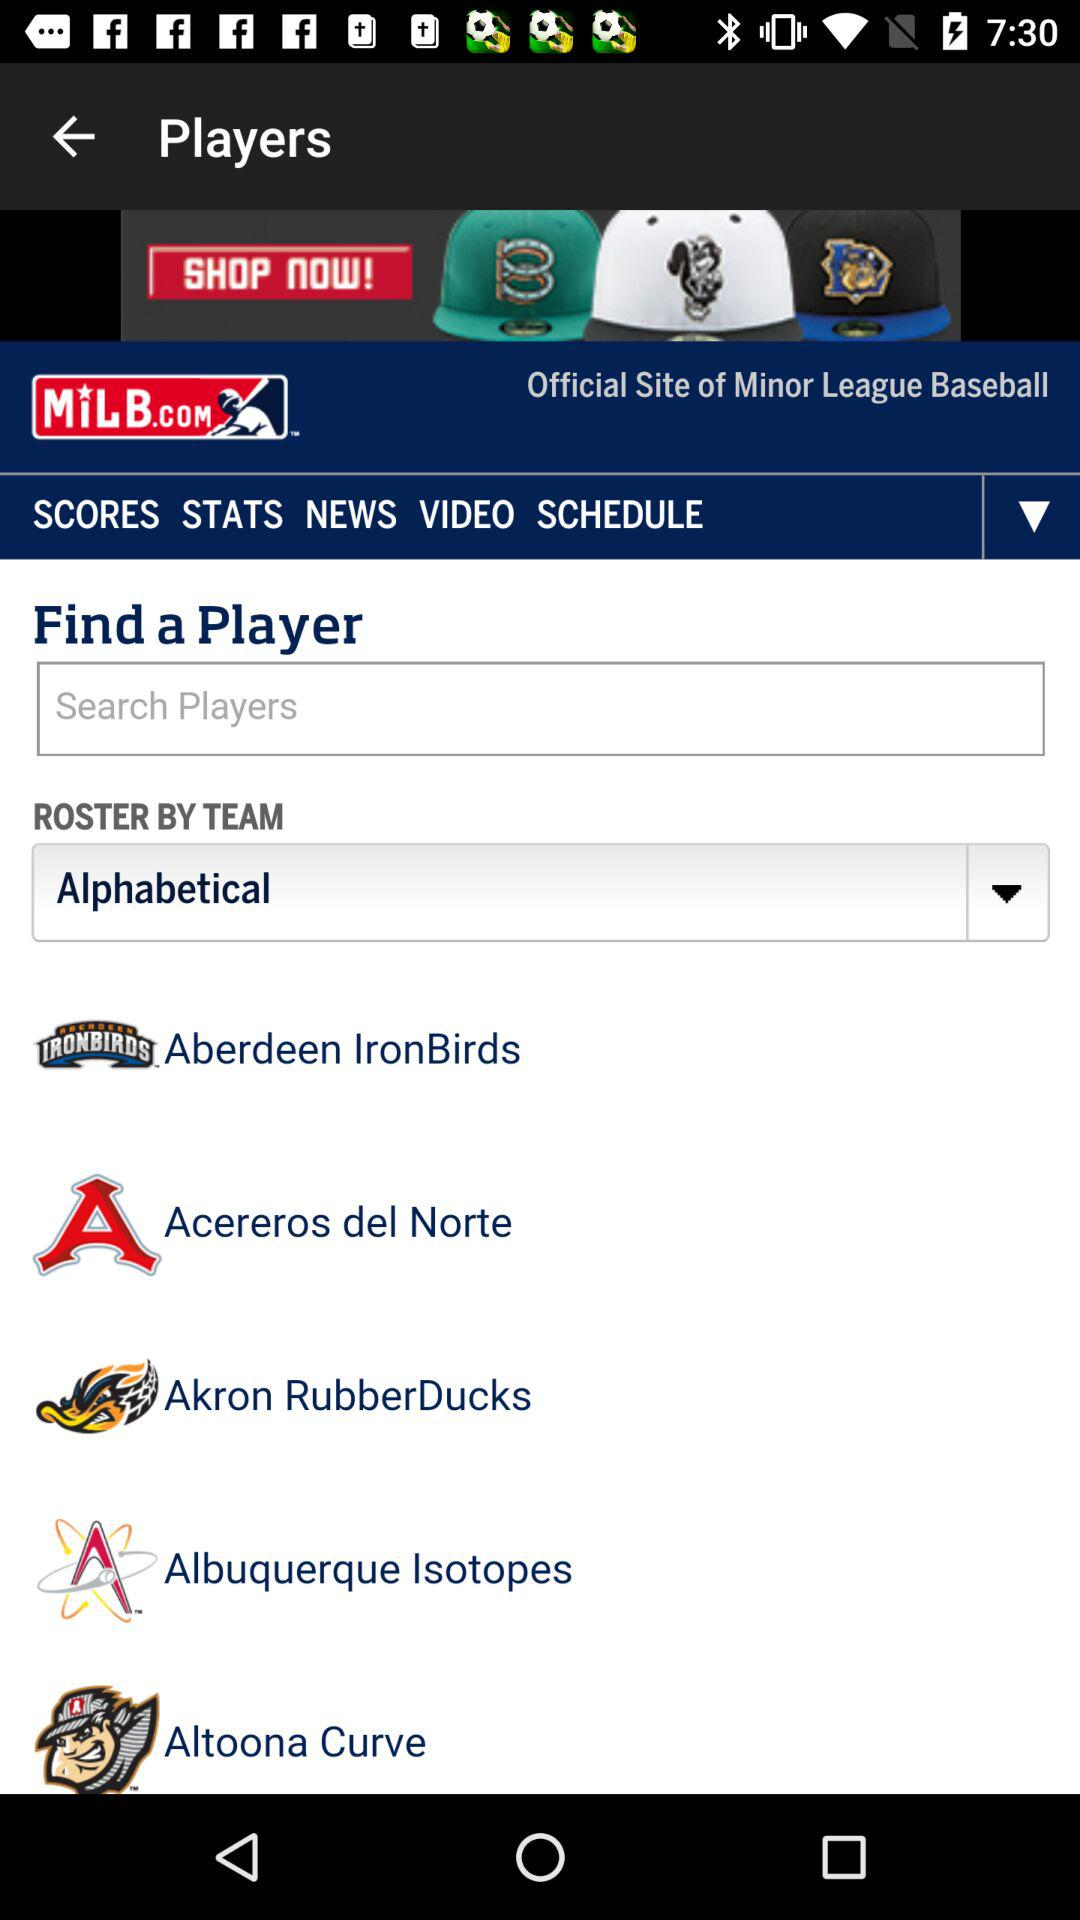What type of roster has been selected? The type of roaster selected is alphabetical. 